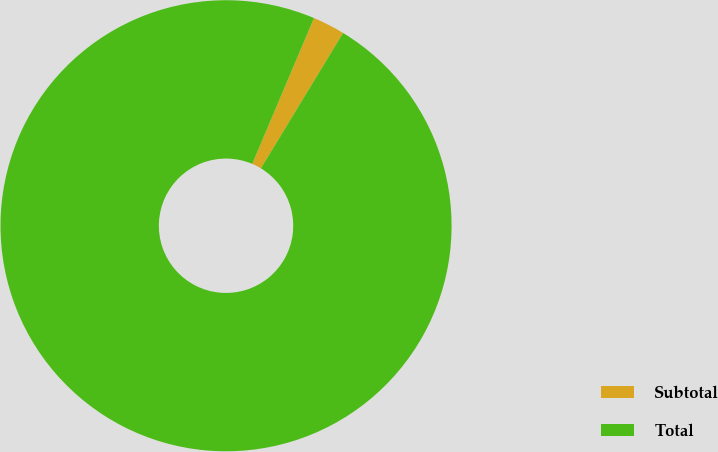<chart> <loc_0><loc_0><loc_500><loc_500><pie_chart><fcel>Subtotal<fcel>Total<nl><fcel>2.31%<fcel>97.69%<nl></chart> 